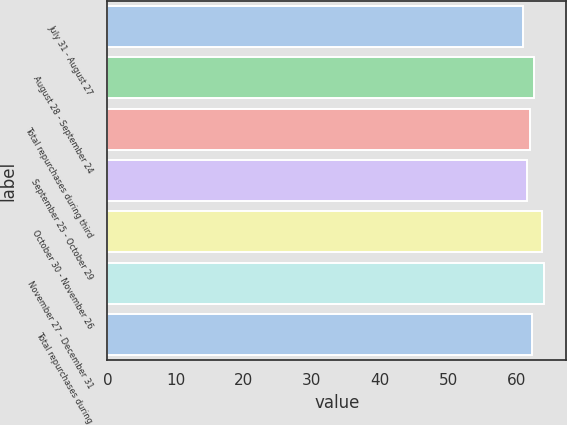Convert chart. <chart><loc_0><loc_0><loc_500><loc_500><bar_chart><fcel>July 31 - August 27<fcel>August 28 - September 24<fcel>Total repurchases during third<fcel>September 25 - October 29<fcel>October 30 - November 26<fcel>November 27 - December 31<fcel>Total repurchases during<nl><fcel>61.02<fcel>62.6<fcel>62.04<fcel>61.62<fcel>63.82<fcel>64.1<fcel>62.32<nl></chart> 